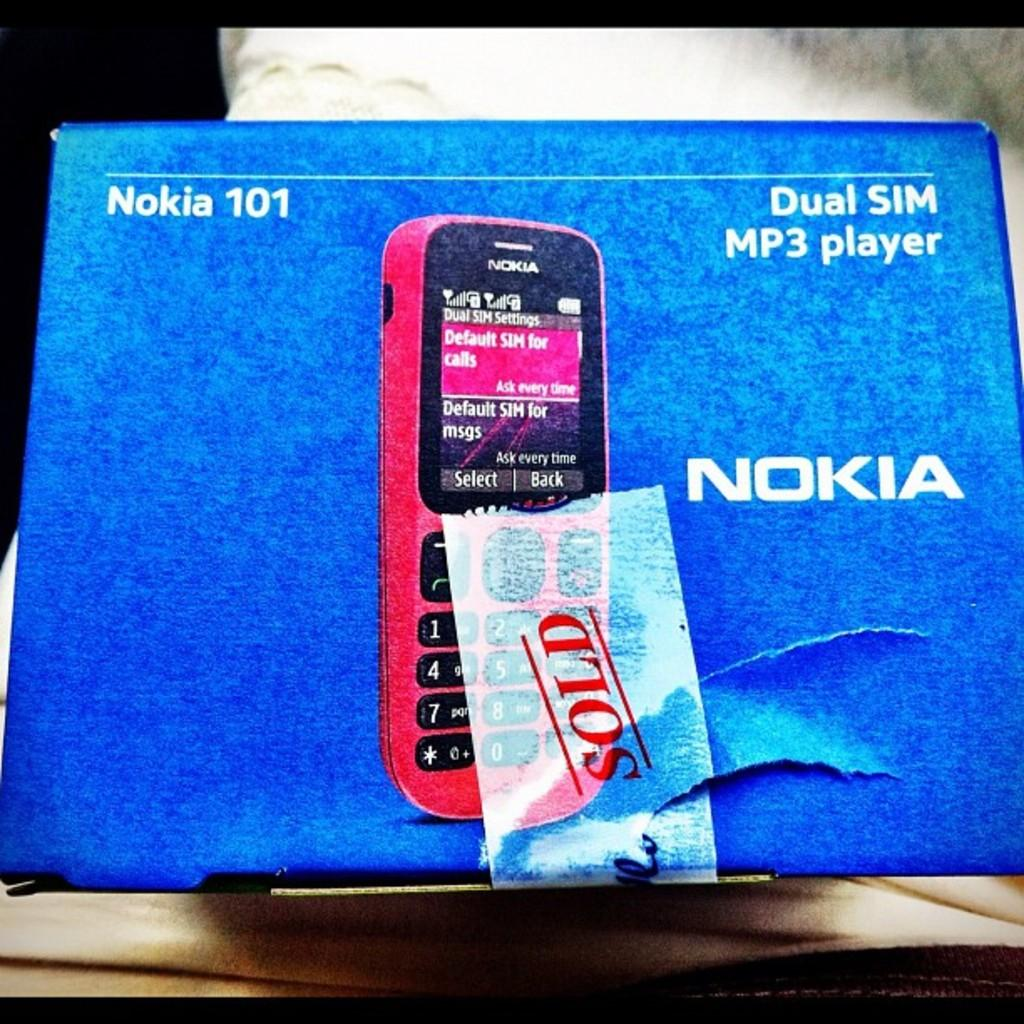<image>
Summarize the visual content of the image. A Nokia 101 with a Dual Sim Mp3 Player box. 